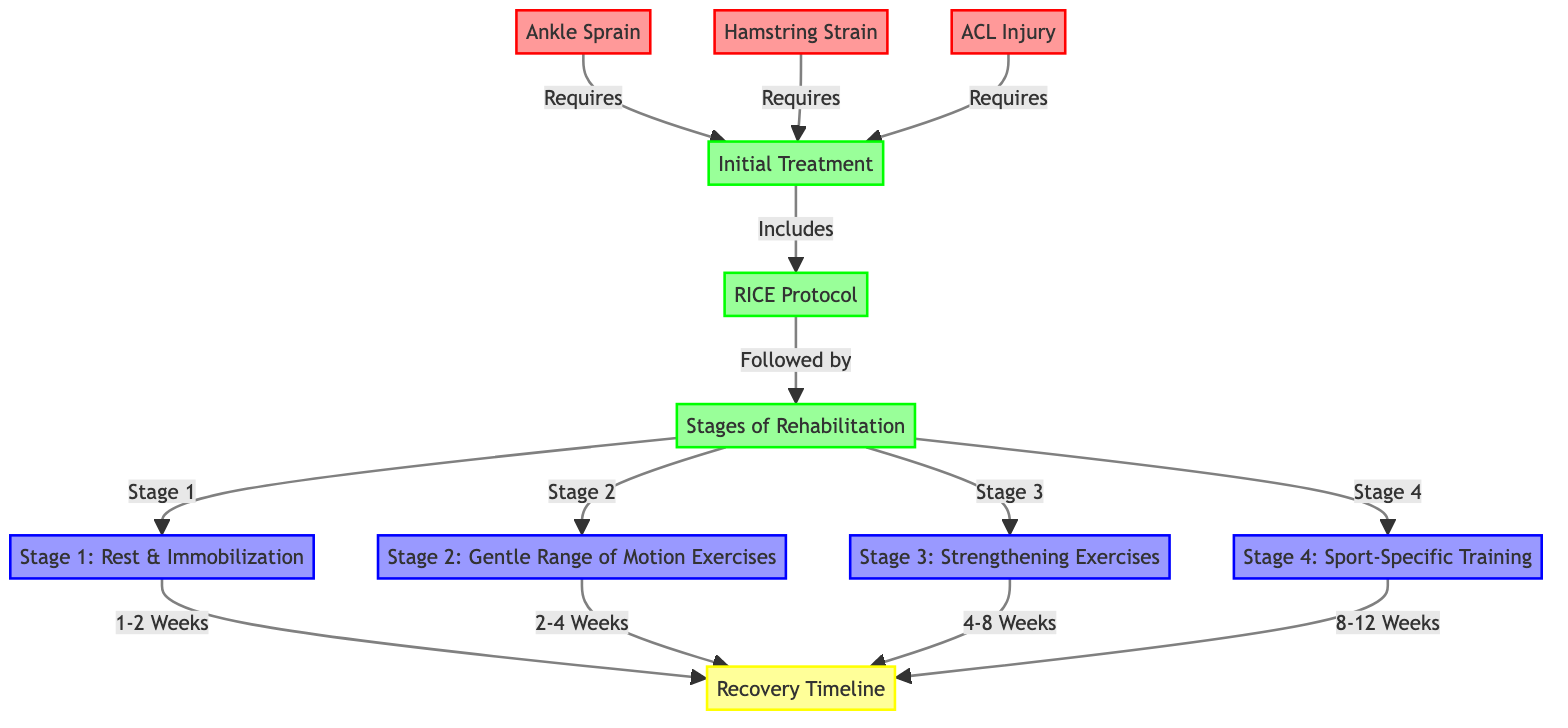What are the three common injuries shown in the diagram? The diagram lists three injuries: Ankle Sprain, Hamstring Strain, and ACL Injury. They are represented as nodes referring to common issues in basketball.
Answer: Ankle Sprain, Hamstring Strain, ACL Injury How many stages of rehabilitation are outlined in the diagram? The diagram outlines four stages of rehabilitation as indicated by the nodes connected to 'Stages of Rehabilitation.' They include: Stage 1, Stage 2, Stage 3, and Stage 4.
Answer: 4 What is the initial treatment protocol referred to in the diagram? The diagram specifies the RICE protocol as the initial treatment that follows the initial treatment node for injuries.
Answer: RICE Protocol Which stage of rehabilitation lasts for 1-2 weeks? According to the diagram, Stage 1 is labeled as Rest & Immobilization and is attributed to a timeline of 1-2 weeks.
Answer: Stage 1: Rest & Immobilization What comes after the implementation of the RICE protocol in the recovery process? The recovery process indicates that after the RICE protocol, the stages of rehabilitation begin, which is marked as the next node in the flow after RICE.
Answer: Stages of Rehabilitation What is the recovery timeline for Strengthening Exercises? In the diagram, Stage 3 pertains to Strengthening Exercises and is linked to a recovery timeline of 4-8 weeks following Stage 2.
Answer: 4-8 Weeks Which injury requires the longest recovery stage according to the diagram? The longest recovery stage is Stage 4, which is Sport-Specific Training, lasting 8-12 weeks. This stage follows all other stages in the rehabilitation process.
Answer: 8-12 Weeks What is the relationship between Ankle Sprain and Initial Treatment? The diagram indicates that Ankle Sprain directly requires Initial Treatment, making this a one-to-one relationship where Ankle Sprain leads to Initial Treatment.
Answer: Requires Which stage includes Gentle Range of Motion Exercises? Stage 2 is identified as Gentle Range of Motion Exercises, labeled directly from the 'Stages of Rehabilitation' node.
Answer: Stage 2: Gentle Range of Motion Exercises 